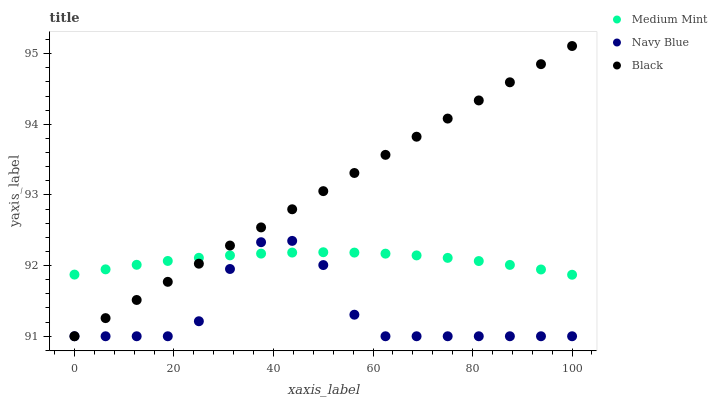Does Navy Blue have the minimum area under the curve?
Answer yes or no. Yes. Does Black have the maximum area under the curve?
Answer yes or no. Yes. Does Black have the minimum area under the curve?
Answer yes or no. No. Does Navy Blue have the maximum area under the curve?
Answer yes or no. No. Is Black the smoothest?
Answer yes or no. Yes. Is Navy Blue the roughest?
Answer yes or no. Yes. Is Navy Blue the smoothest?
Answer yes or no. No. Is Black the roughest?
Answer yes or no. No. Does Navy Blue have the lowest value?
Answer yes or no. Yes. Does Black have the highest value?
Answer yes or no. Yes. Does Navy Blue have the highest value?
Answer yes or no. No. Does Black intersect Navy Blue?
Answer yes or no. Yes. Is Black less than Navy Blue?
Answer yes or no. No. Is Black greater than Navy Blue?
Answer yes or no. No. 